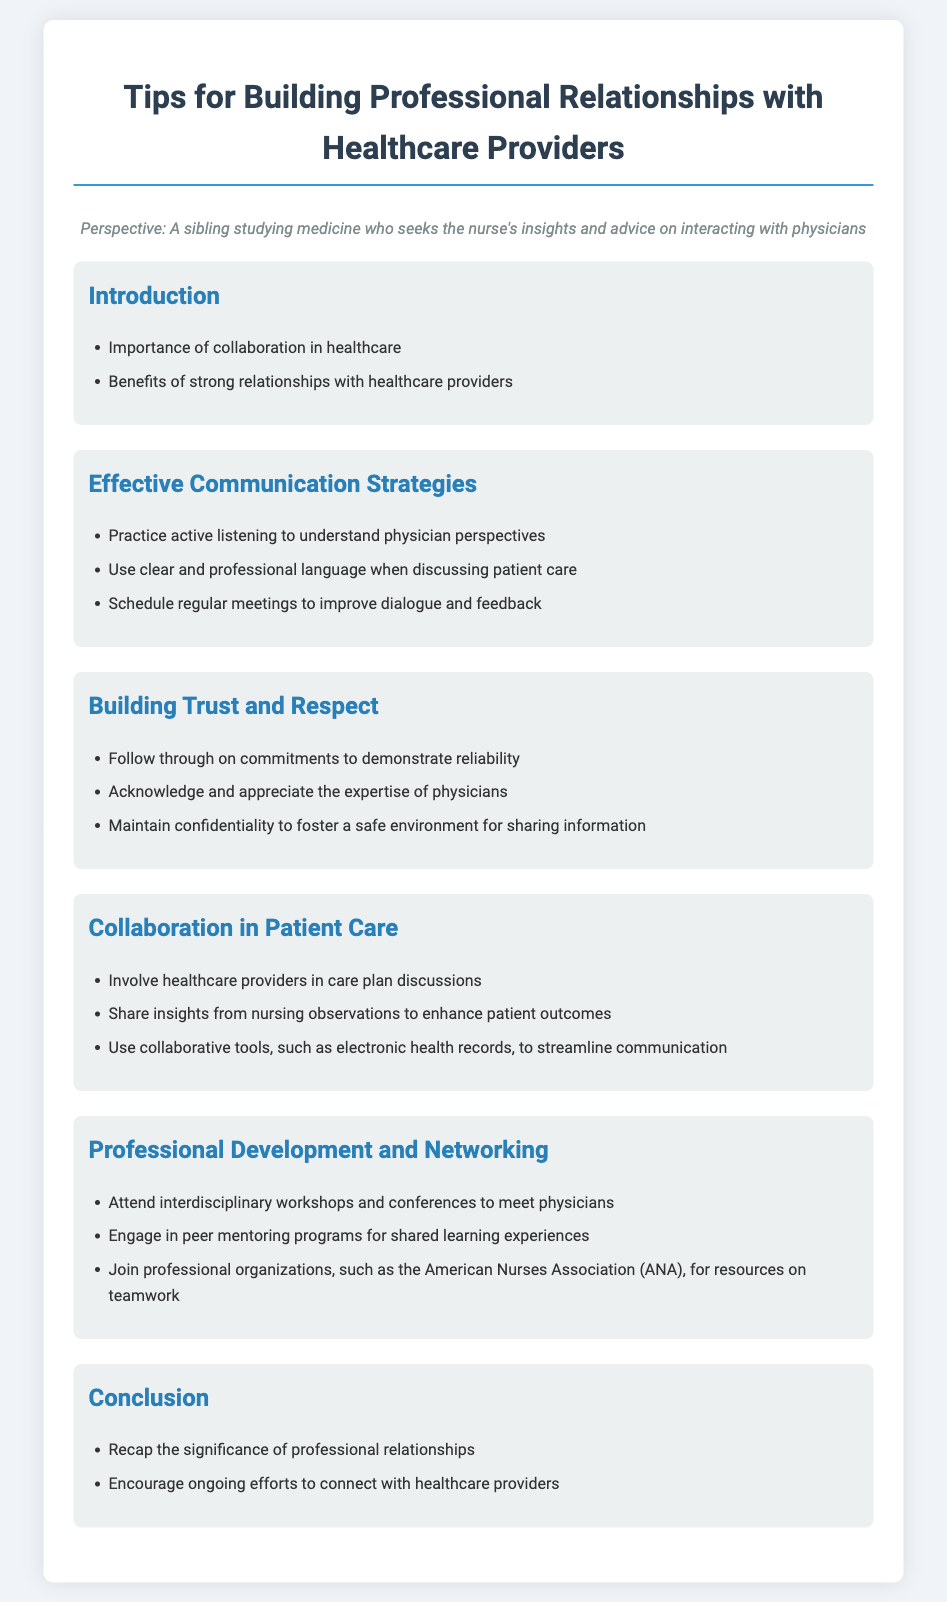what is the title of the document? The title is located at the top of the rendered document, which describes the content regarding professional relationships.
Answer: Tips for Building Professional Relationships with Healthcare Providers how many effective communication strategies are listed? The number of strategies is found in the section detailing effective communication strategies.
Answer: three name one way to build trust and respect. This is found under the section about building trust and respect, detailing specific behaviors that aid in relationship building.
Answer: Follow through on commitments what is one tool suggested for collaboration in patient care? The document lists specific collaborative tools in the related section that enhance communication.
Answer: electronic health records what professional organization is mentioned for resources? The document refers to specific professional organizations that provide resources for teamwork in the nursing field.
Answer: American Nurses Association what is emphasized in the conclusion? The conclusion summarizes key takeaways and themes from the document, particularly about relationships with healthcare providers.
Answer: significance of professional relationships how many sections are there in the document? The total number of sections is counted from the main headings presented in the agenda.
Answer: six name one benefit of strong relationships with healthcare providers. Benefits are outlined in the introduction section, highlighting key advantages of collaboration.
Answer: collaboration in healthcare 